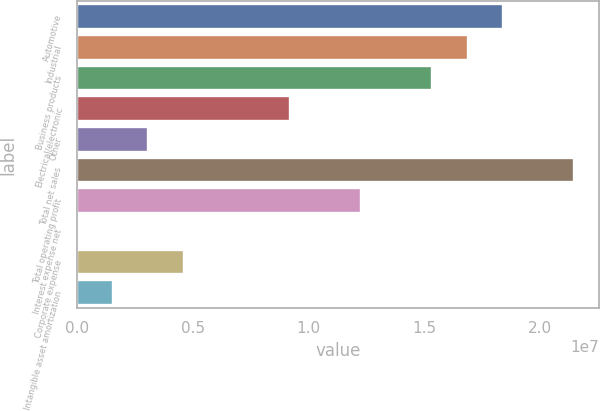<chart> <loc_0><loc_0><loc_500><loc_500><bar_chart><fcel>Automotive<fcel>Industrial<fcel>Business products<fcel>Electrical/electronic<fcel>Other<fcel>Total net sales<fcel>Total operating profit<fcel>Interest expense net<fcel>Corporate expense<fcel>Intangible asset amortization<nl><fcel>1.84051e+07<fcel>1.68734e+07<fcel>1.53416e+07<fcel>9.21466e+06<fcel>3.08768e+06<fcel>2.14686e+07<fcel>1.22782e+07<fcel>24192<fcel>4.61943e+06<fcel>1.55594e+06<nl></chart> 